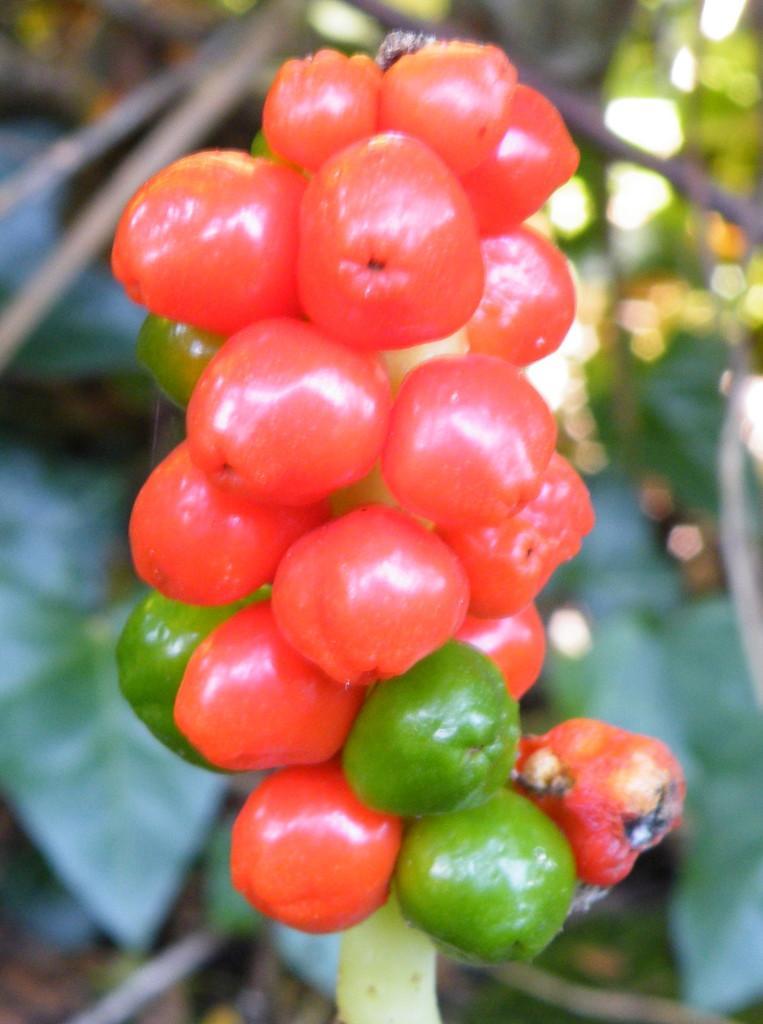Please provide a concise description of this image. This is a zoomed in picture. In the center we can see the red and green color objects which seems to be the fruits. In the background we can see many other objects. 